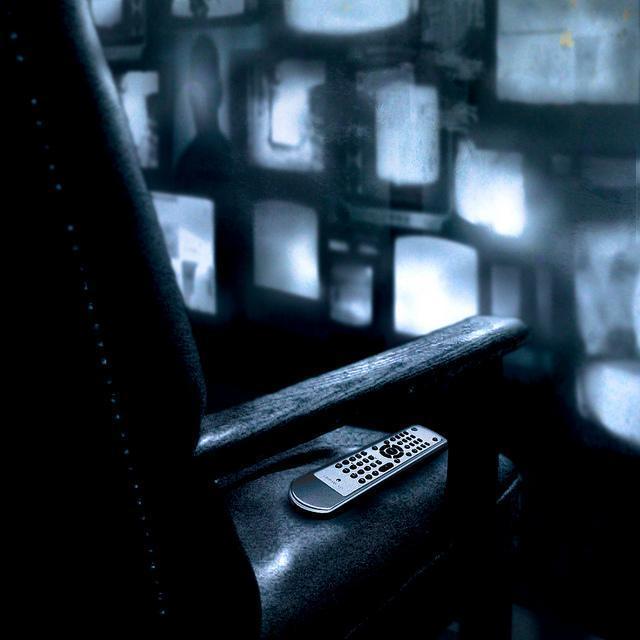How many tvs can you see?
Give a very brief answer. 11. How many men have no shirts on?
Give a very brief answer. 0. 